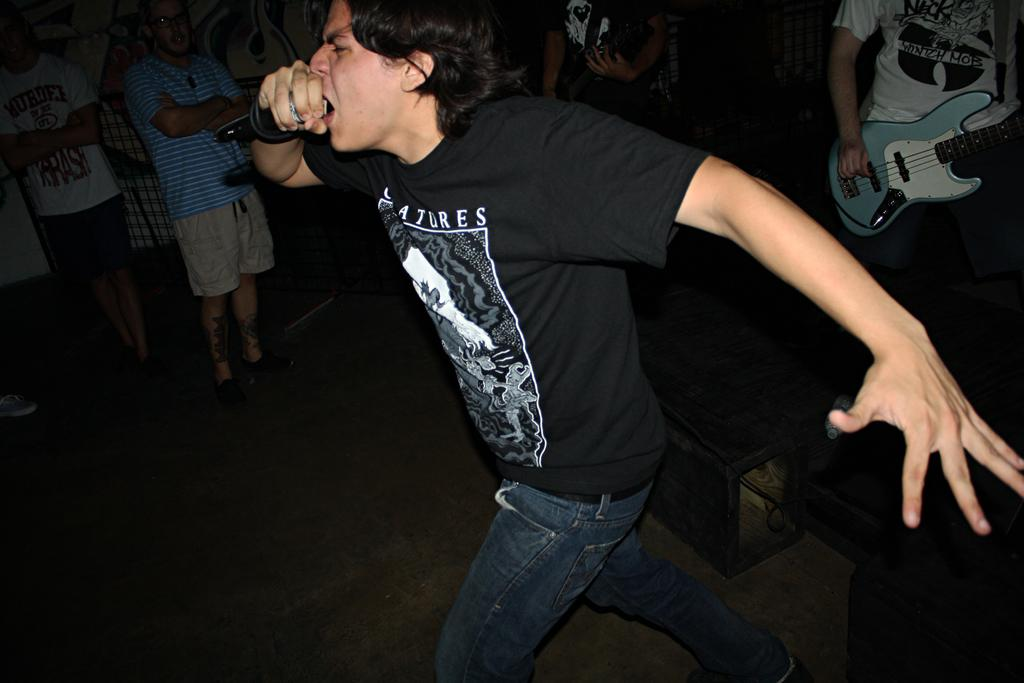What is the man in the image doing? The man in the image is singing. What is the man holding while singing? The man is holding a microphone in his hand. Are there any other musicians in the image? Yes, there are two members in the background playing guitars. Are there any spectators in the image? Yes, some people are watching the performance. What type of parcel is being delivered to the man while he sings? There is no parcel being delivered to the man in the image; he is simply singing with a microphone. 